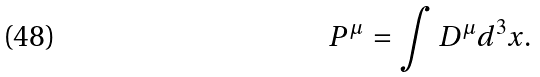<formula> <loc_0><loc_0><loc_500><loc_500>P ^ { \mu } = \int D ^ { \mu } d ^ { 3 } x .</formula> 